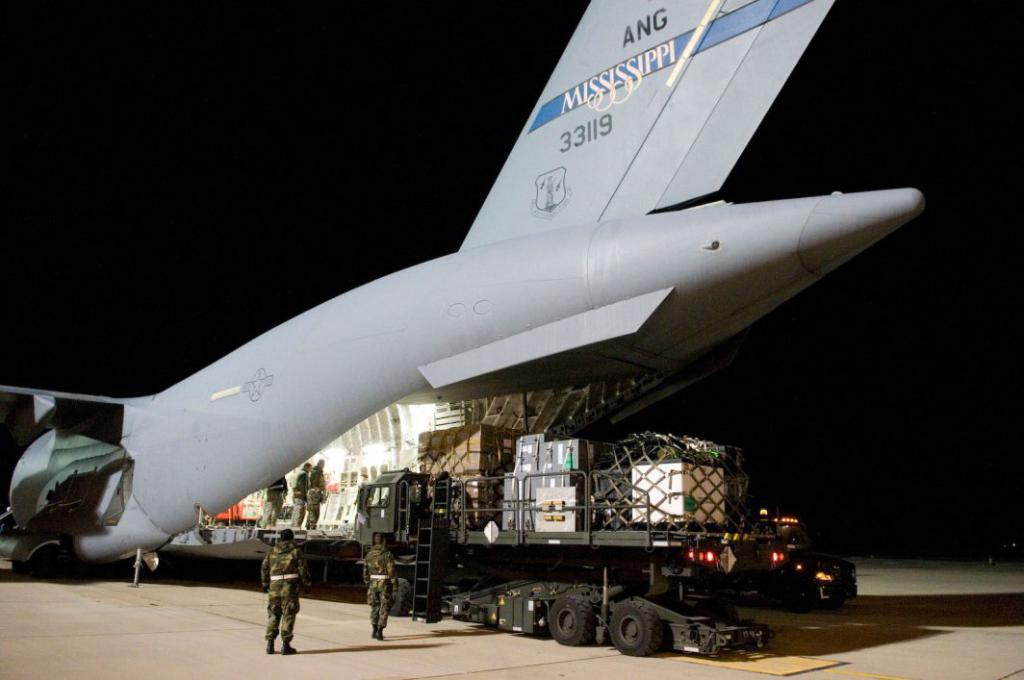Please provide a concise description of this image. In this image we can see an aeroplane. There is a truck. There are people. At the bottom of the image there is road. At the top of the image there is sky. 